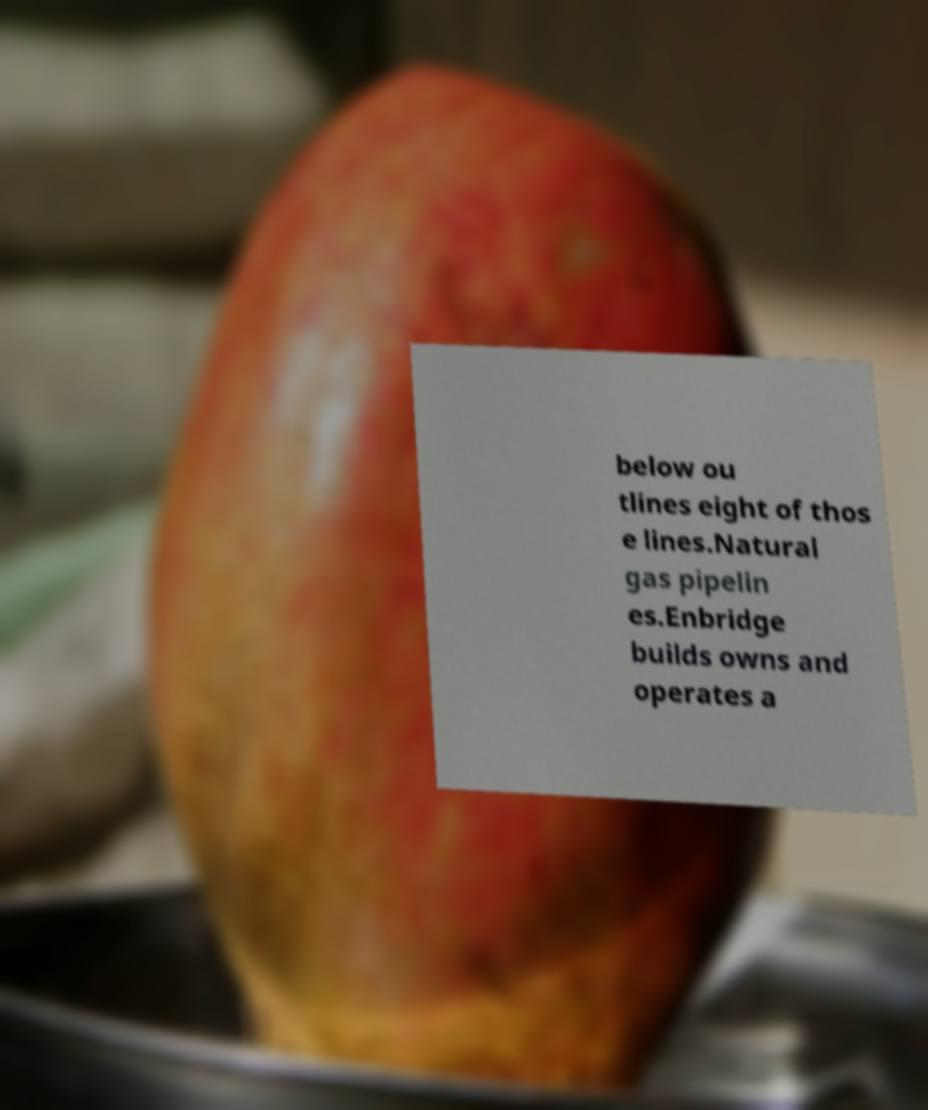I need the written content from this picture converted into text. Can you do that? below ou tlines eight of thos e lines.Natural gas pipelin es.Enbridge builds owns and operates a 